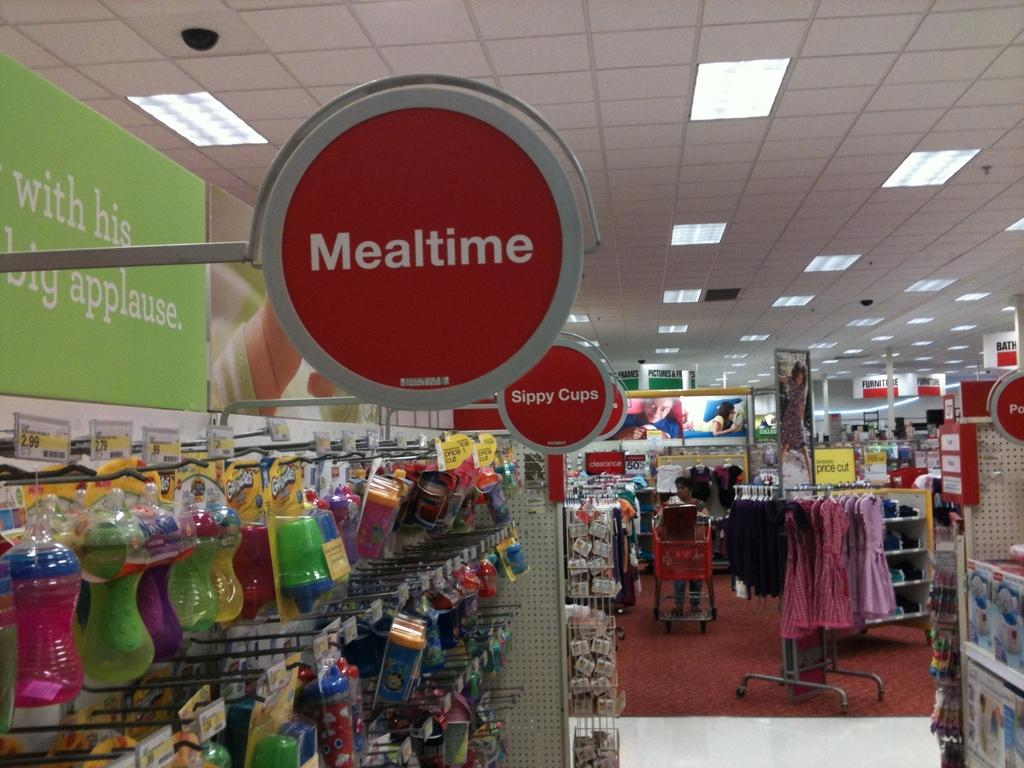<image>
Describe the image concisely. People shopping in a store at the Mealtime  and Sippycup sections. 